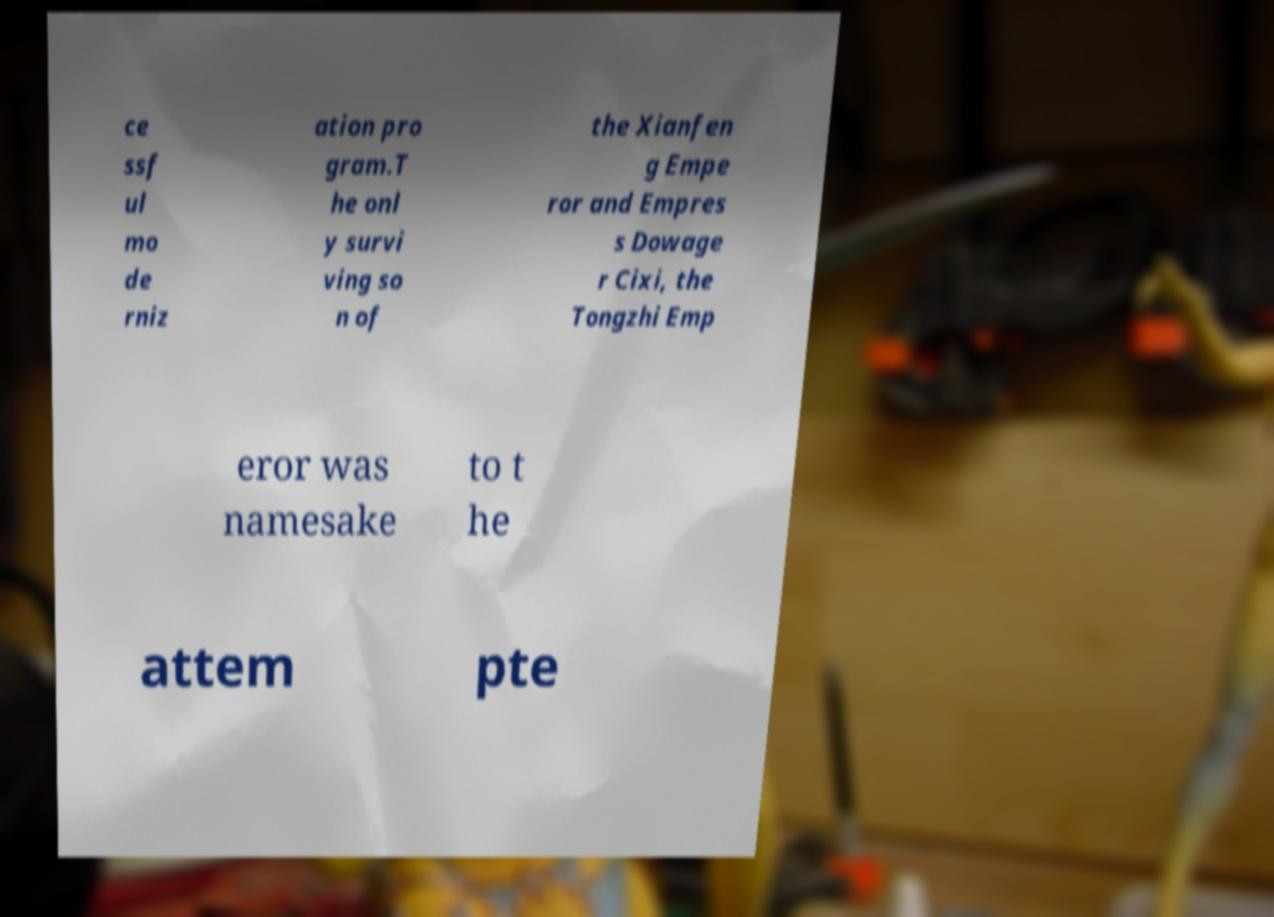I need the written content from this picture converted into text. Can you do that? ce ssf ul mo de rniz ation pro gram.T he onl y survi ving so n of the Xianfen g Empe ror and Empres s Dowage r Cixi, the Tongzhi Emp eror was namesake to t he attem pte 